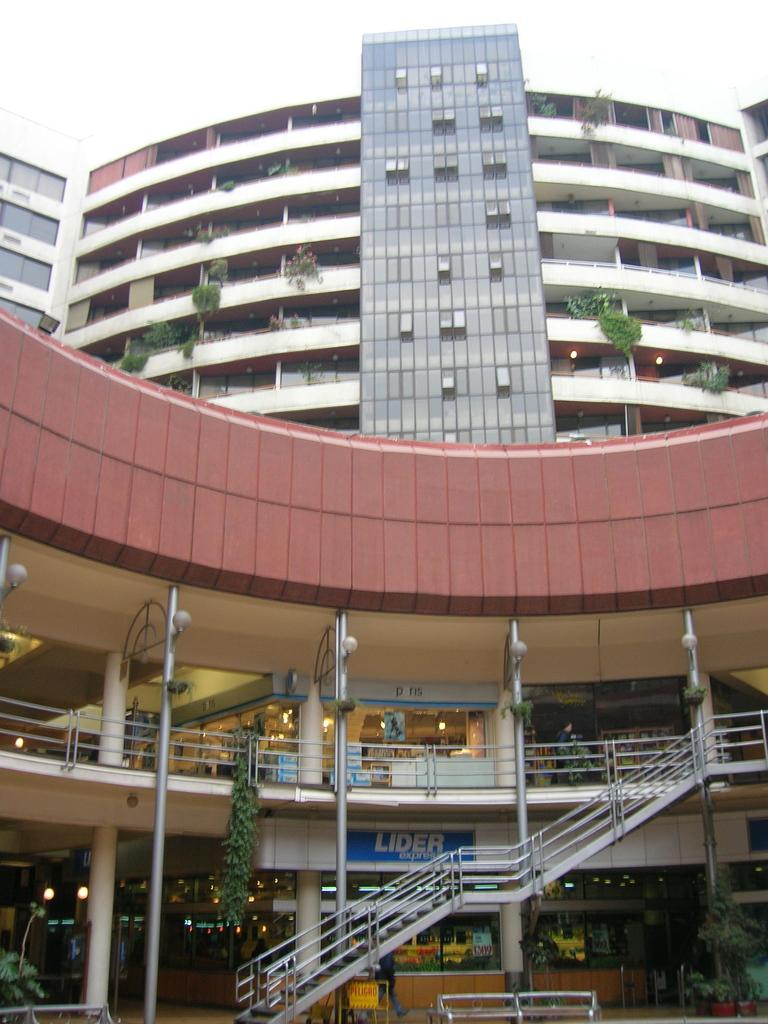<image>
Provide a brief description of the given image. Lider Express is advertised behind the stairwell at the base of this building. 